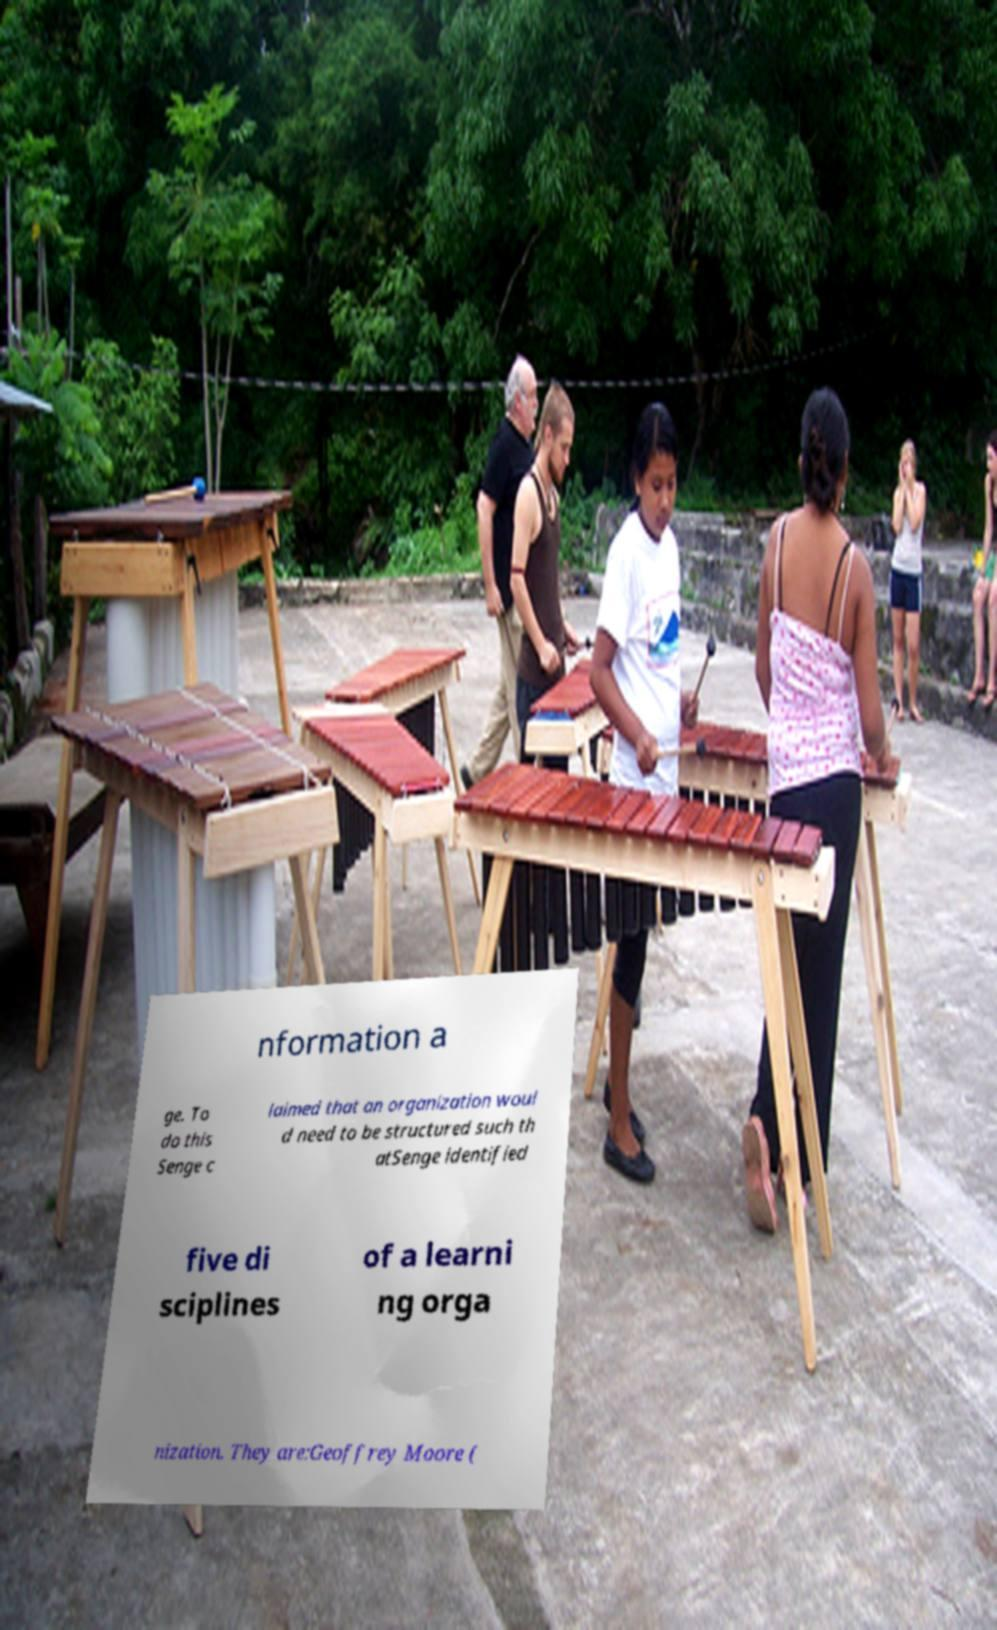Could you assist in decoding the text presented in this image and type it out clearly? nformation a ge. To do this Senge c laimed that an organization woul d need to be structured such th atSenge identified five di sciplines of a learni ng orga nization. They are:Geoffrey Moore ( 